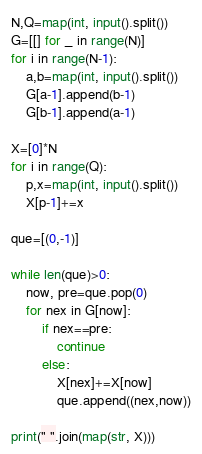<code> <loc_0><loc_0><loc_500><loc_500><_Python_>N,Q=map(int, input().split())
G=[[] for _ in range(N)]
for i in range(N-1):
    a,b=map(int, input().split())
    G[a-1].append(b-1)
    G[b-1].append(a-1)

X=[0]*N
for i in range(Q):
    p,x=map(int, input().split())
    X[p-1]+=x

que=[(0,-1)]

while len(que)>0:
    now, pre=que.pop(0)
    for nex in G[now]:
        if nex==pre:
            continue
        else:
            X[nex]+=X[now]
            que.append((nex,now))

print(" ".join(map(str, X)))</code> 